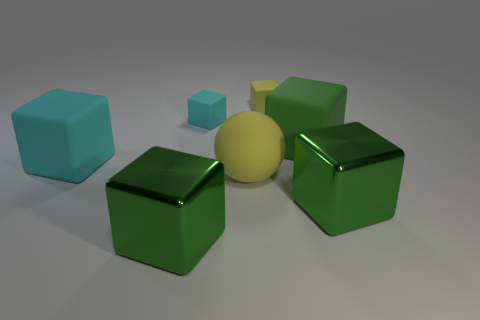What number of matte things are big cyan cubes or big yellow spheres?
Your answer should be compact. 2. What is the shape of the green rubber thing?
Your response must be concise. Cube. There is a cyan block that is the same size as the matte sphere; what is its material?
Your answer should be compact. Rubber. What number of small things are yellow matte objects or brown metallic blocks?
Offer a terse response. 1. Are any metal cylinders visible?
Make the answer very short. No. What is the size of the yellow block that is made of the same material as the big cyan block?
Provide a succinct answer. Small. How many other objects are there of the same material as the yellow sphere?
Give a very brief answer. 4. How many green blocks are to the right of the tiny yellow block and in front of the large yellow ball?
Give a very brief answer. 1. What is the color of the rubber sphere?
Your response must be concise. Yellow. There is a large yellow matte object that is behind the large shiny object that is to the left of the sphere; what shape is it?
Give a very brief answer. Sphere. 